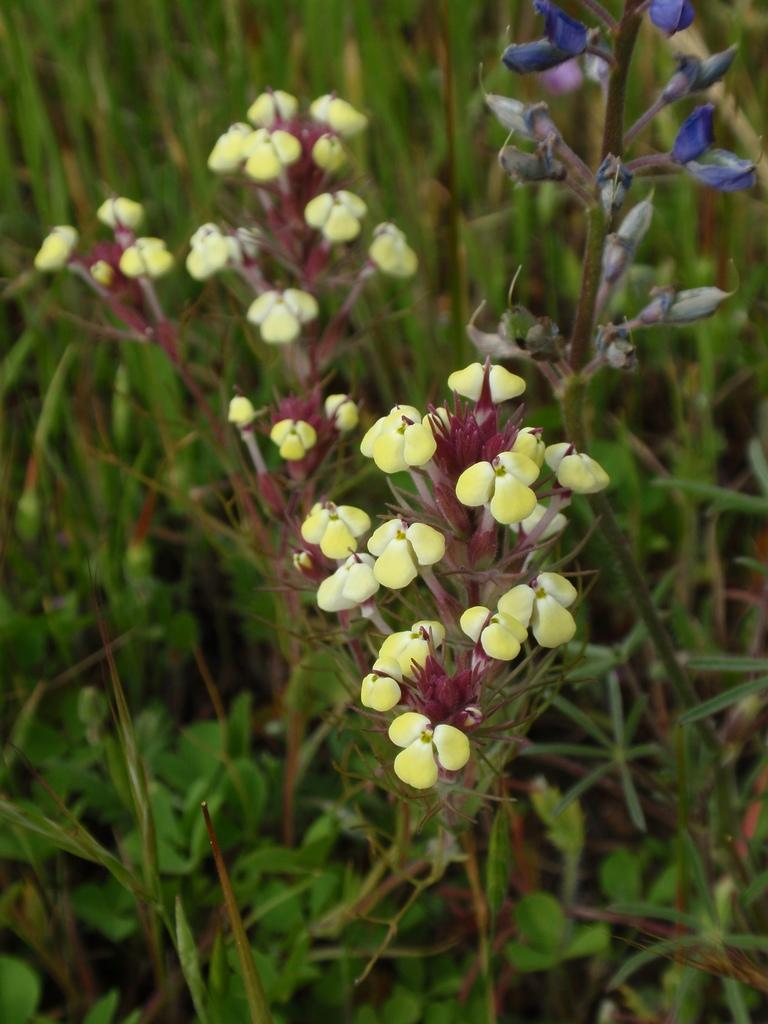What type of living organisms can be seen in the image? Plants can be seen in the image. What specific features can be observed on the plants? The plants have flowers and buds. Is there a bridge visible in the image? No, there is no bridge present in the image. Can you see a worm crawling on the plants in the image? No, there is no worm visible in the image. 